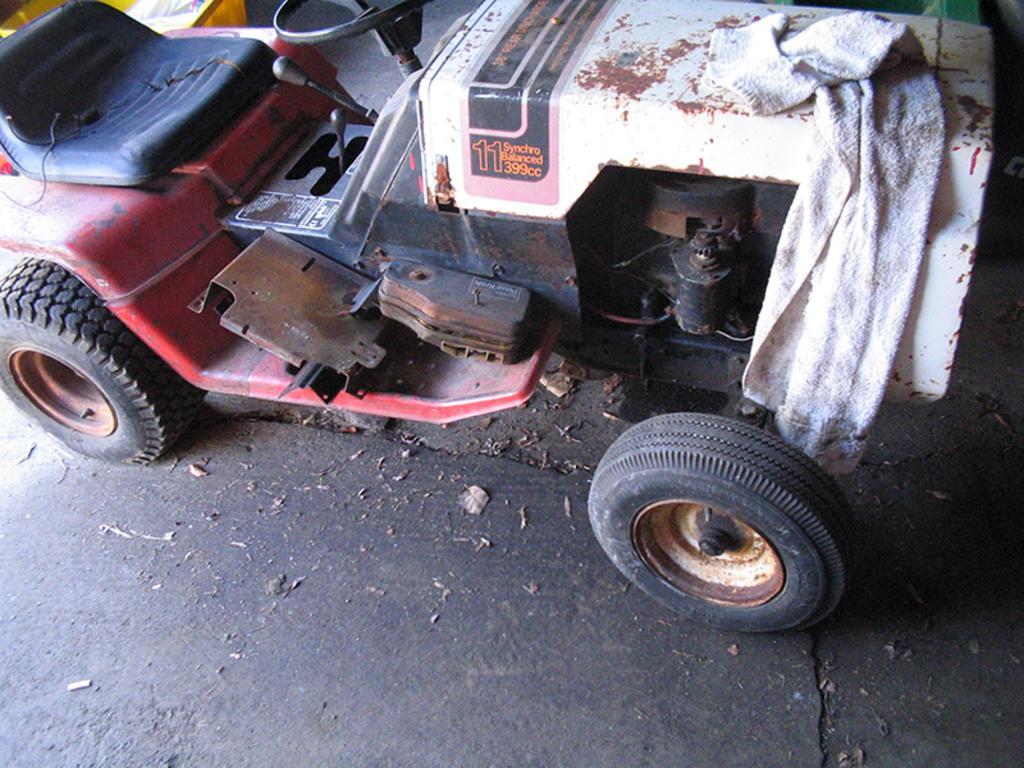What type of object is in the image? There is a motor vehicle in the image. What is covering the motor vehicle? A cloth is placed on the motor vehicle. Where are the motor vehicle and the cloth located? The motor vehicle and the cloth are on the floor. What type of celery is being used as a decoration on the motor vehicle? There is no celery present in the image; it only features a motor vehicle and a cloth. 